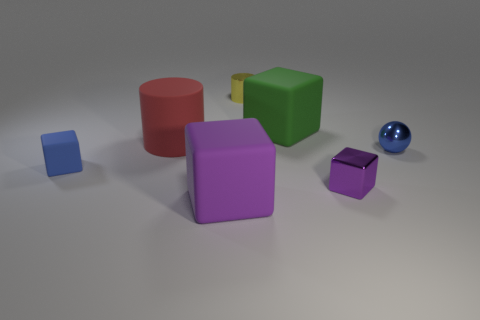Is there a small yellow thing that has the same shape as the large red rubber object?
Make the answer very short. Yes. Are there the same number of metal cubes that are left of the red rubber thing and big yellow metallic cylinders?
Give a very brief answer. Yes. What is the block behind the blue object that is right of the small yellow object made of?
Keep it short and to the point. Rubber. What shape is the yellow metal object?
Provide a succinct answer. Cylinder. Is the number of objects behind the blue rubber thing the same as the number of large purple matte cubes that are in front of the big purple cube?
Keep it short and to the point. No. There is a big matte block in front of the green rubber thing; is its color the same as the small thing behind the large red matte cylinder?
Your response must be concise. No. Are there more small yellow things that are right of the green object than blue shiny things?
Offer a terse response. No. There is a big red object that is made of the same material as the big purple thing; what shape is it?
Make the answer very short. Cylinder. Do the purple cube that is on the right side of the yellow cylinder and the blue rubber object have the same size?
Your answer should be very brief. Yes. What shape is the big matte thing that is in front of the tiny blue object that is on the right side of the purple matte thing?
Your answer should be compact. Cube. 